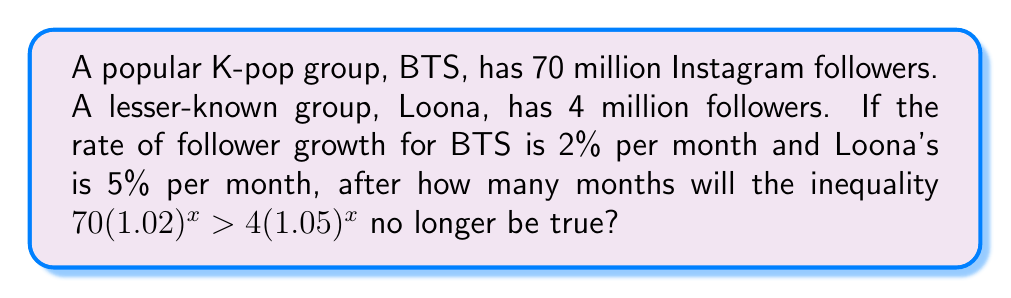Help me with this question. Let's approach this step-by-step:

1) The inequality $70(1.02)^x > 4(1.05)^x$ represents the comparison of followers over time, where $x$ is the number of months.

2) To find when this inequality is no longer true, we need to solve for equality:

   $70(1.02)^x = 4(1.05)^x$

3) Divide both sides by 4:

   $17.5(1.02)^x = (1.05)^x$

4) Take the natural log of both sides:

   $\ln(17.5) + x\ln(1.02) = x\ln(1.05)$

5) Rearrange the equation:

   $\ln(17.5) = x\ln(1.05) - x\ln(1.02)$
   $\ln(17.5) = x(\ln(1.05) - \ln(1.02))$

6) Solve for $x$:

   $x = \frac{\ln(17.5)}{\ln(1.05) - \ln(1.02)}$

7) Calculate the value:

   $x \approx 61.78$ months

8) Since we're looking for when the inequality is no longer true, we need to round up to the next whole month.

Therefore, after 62 months, the inequality will no longer hold true.
Answer: 62 months 